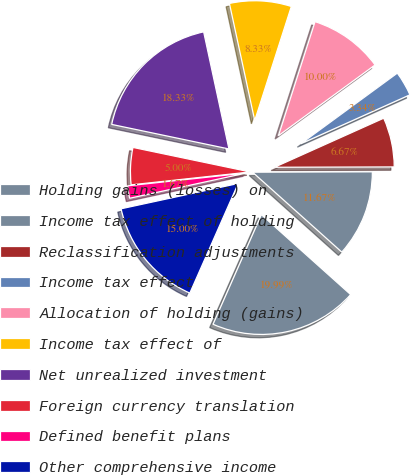<chart> <loc_0><loc_0><loc_500><loc_500><pie_chart><fcel>Holding gains (losses) on<fcel>Income tax effect of holding<fcel>Reclassification adjustments<fcel>Income tax effect<fcel>Allocation of holding (gains)<fcel>Income tax effect of<fcel>Net unrealized investment<fcel>Foreign currency translation<fcel>Defined benefit plans<fcel>Other comprehensive income<nl><fcel>19.99%<fcel>11.67%<fcel>6.67%<fcel>3.34%<fcel>10.0%<fcel>8.33%<fcel>18.33%<fcel>5.0%<fcel>1.67%<fcel>15.0%<nl></chart> 